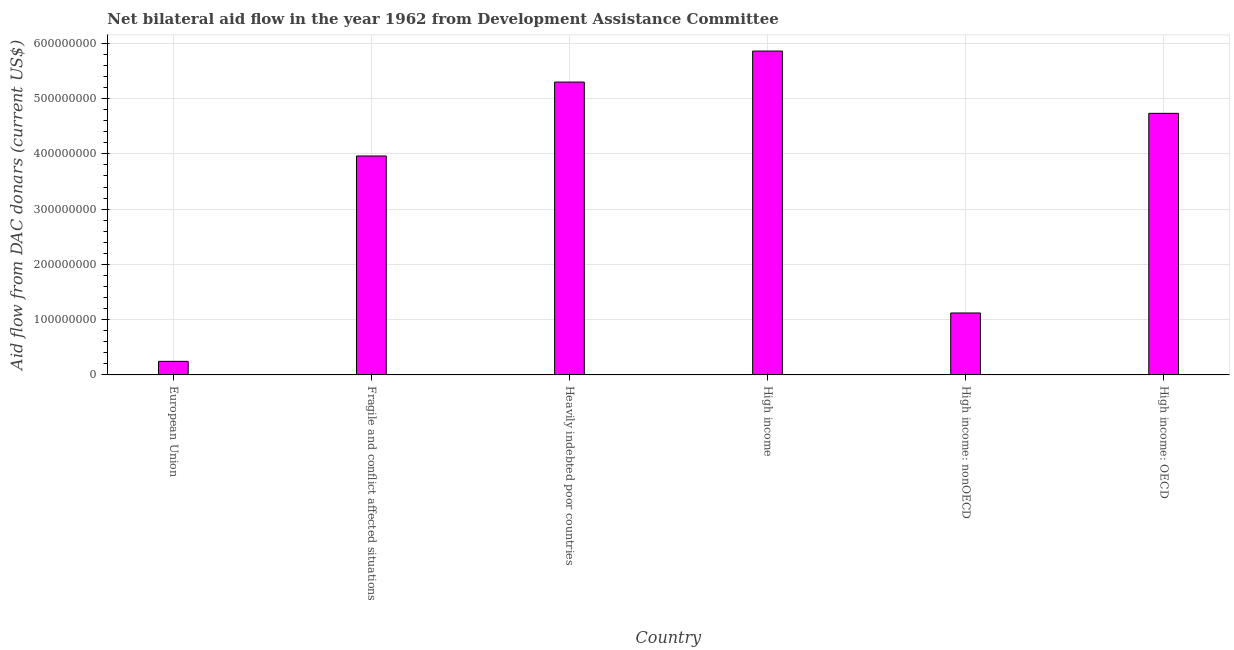Does the graph contain any zero values?
Give a very brief answer. No. Does the graph contain grids?
Offer a terse response. Yes. What is the title of the graph?
Ensure brevity in your answer.  Net bilateral aid flow in the year 1962 from Development Assistance Committee. What is the label or title of the X-axis?
Offer a very short reply. Country. What is the label or title of the Y-axis?
Keep it short and to the point. Aid flow from DAC donars (current US$). What is the net bilateral aid flows from dac donors in European Union?
Provide a short and direct response. 2.46e+07. Across all countries, what is the maximum net bilateral aid flows from dac donors?
Your answer should be compact. 5.86e+08. Across all countries, what is the minimum net bilateral aid flows from dac donors?
Provide a succinct answer. 2.46e+07. In which country was the net bilateral aid flows from dac donors minimum?
Offer a terse response. European Union. What is the sum of the net bilateral aid flows from dac donors?
Ensure brevity in your answer.  2.12e+09. What is the difference between the net bilateral aid flows from dac donors in High income and High income: OECD?
Offer a very short reply. 1.13e+08. What is the average net bilateral aid flows from dac donors per country?
Provide a short and direct response. 3.54e+08. What is the median net bilateral aid flows from dac donors?
Offer a terse response. 4.35e+08. In how many countries, is the net bilateral aid flows from dac donors greater than 300000000 US$?
Provide a short and direct response. 4. What is the ratio of the net bilateral aid flows from dac donors in European Union to that in Heavily indebted poor countries?
Keep it short and to the point. 0.05. Is the net bilateral aid flows from dac donors in European Union less than that in High income?
Give a very brief answer. Yes. What is the difference between the highest and the second highest net bilateral aid flows from dac donors?
Keep it short and to the point. 5.61e+07. What is the difference between the highest and the lowest net bilateral aid flows from dac donors?
Offer a terse response. 5.62e+08. How many bars are there?
Offer a very short reply. 6. How many countries are there in the graph?
Your answer should be compact. 6. What is the Aid flow from DAC donars (current US$) in European Union?
Keep it short and to the point. 2.46e+07. What is the Aid flow from DAC donars (current US$) of Fragile and conflict affected situations?
Keep it short and to the point. 3.96e+08. What is the Aid flow from DAC donars (current US$) of Heavily indebted poor countries?
Keep it short and to the point. 5.30e+08. What is the Aid flow from DAC donars (current US$) of High income?
Provide a succinct answer. 5.86e+08. What is the Aid flow from DAC donars (current US$) in High income: nonOECD?
Provide a short and direct response. 1.12e+08. What is the Aid flow from DAC donars (current US$) in High income: OECD?
Offer a terse response. 4.73e+08. What is the difference between the Aid flow from DAC donars (current US$) in European Union and Fragile and conflict affected situations?
Offer a terse response. -3.72e+08. What is the difference between the Aid flow from DAC donars (current US$) in European Union and Heavily indebted poor countries?
Offer a very short reply. -5.05e+08. What is the difference between the Aid flow from DAC donars (current US$) in European Union and High income?
Provide a short and direct response. -5.62e+08. What is the difference between the Aid flow from DAC donars (current US$) in European Union and High income: nonOECD?
Give a very brief answer. -8.75e+07. What is the difference between the Aid flow from DAC donars (current US$) in European Union and High income: OECD?
Your answer should be very brief. -4.49e+08. What is the difference between the Aid flow from DAC donars (current US$) in Fragile and conflict affected situations and Heavily indebted poor countries?
Provide a succinct answer. -1.34e+08. What is the difference between the Aid flow from DAC donars (current US$) in Fragile and conflict affected situations and High income?
Provide a short and direct response. -1.90e+08. What is the difference between the Aid flow from DAC donars (current US$) in Fragile and conflict affected situations and High income: nonOECD?
Ensure brevity in your answer.  2.84e+08. What is the difference between the Aid flow from DAC donars (current US$) in Fragile and conflict affected situations and High income: OECD?
Offer a terse response. -7.71e+07. What is the difference between the Aid flow from DAC donars (current US$) in Heavily indebted poor countries and High income?
Ensure brevity in your answer.  -5.61e+07. What is the difference between the Aid flow from DAC donars (current US$) in Heavily indebted poor countries and High income: nonOECD?
Provide a short and direct response. 4.18e+08. What is the difference between the Aid flow from DAC donars (current US$) in Heavily indebted poor countries and High income: OECD?
Your answer should be very brief. 5.66e+07. What is the difference between the Aid flow from DAC donars (current US$) in High income and High income: nonOECD?
Your answer should be compact. 4.74e+08. What is the difference between the Aid flow from DAC donars (current US$) in High income and High income: OECD?
Your answer should be very brief. 1.13e+08. What is the difference between the Aid flow from DAC donars (current US$) in High income: nonOECD and High income: OECD?
Keep it short and to the point. -3.61e+08. What is the ratio of the Aid flow from DAC donars (current US$) in European Union to that in Fragile and conflict affected situations?
Your response must be concise. 0.06. What is the ratio of the Aid flow from DAC donars (current US$) in European Union to that in Heavily indebted poor countries?
Make the answer very short. 0.05. What is the ratio of the Aid flow from DAC donars (current US$) in European Union to that in High income?
Ensure brevity in your answer.  0.04. What is the ratio of the Aid flow from DAC donars (current US$) in European Union to that in High income: nonOECD?
Give a very brief answer. 0.22. What is the ratio of the Aid flow from DAC donars (current US$) in European Union to that in High income: OECD?
Keep it short and to the point. 0.05. What is the ratio of the Aid flow from DAC donars (current US$) in Fragile and conflict affected situations to that in Heavily indebted poor countries?
Your response must be concise. 0.75. What is the ratio of the Aid flow from DAC donars (current US$) in Fragile and conflict affected situations to that in High income?
Your answer should be compact. 0.68. What is the ratio of the Aid flow from DAC donars (current US$) in Fragile and conflict affected situations to that in High income: nonOECD?
Your response must be concise. 3.54. What is the ratio of the Aid flow from DAC donars (current US$) in Fragile and conflict affected situations to that in High income: OECD?
Give a very brief answer. 0.84. What is the ratio of the Aid flow from DAC donars (current US$) in Heavily indebted poor countries to that in High income?
Your response must be concise. 0.9. What is the ratio of the Aid flow from DAC donars (current US$) in Heavily indebted poor countries to that in High income: nonOECD?
Give a very brief answer. 4.73. What is the ratio of the Aid flow from DAC donars (current US$) in Heavily indebted poor countries to that in High income: OECD?
Provide a short and direct response. 1.12. What is the ratio of the Aid flow from DAC donars (current US$) in High income to that in High income: nonOECD?
Keep it short and to the point. 5.23. What is the ratio of the Aid flow from DAC donars (current US$) in High income to that in High income: OECD?
Ensure brevity in your answer.  1.24. What is the ratio of the Aid flow from DAC donars (current US$) in High income: nonOECD to that in High income: OECD?
Your answer should be very brief. 0.24. 